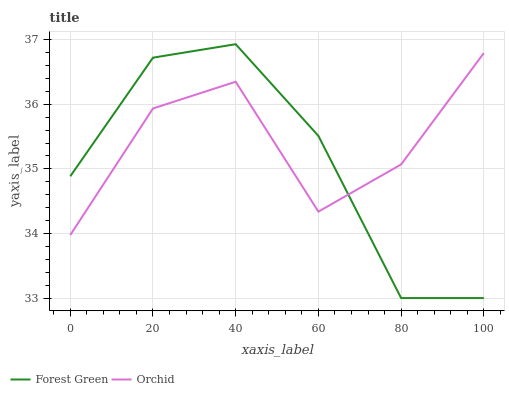Does Forest Green have the minimum area under the curve?
Answer yes or no. Yes. Does Orchid have the maximum area under the curve?
Answer yes or no. Yes. Does Orchid have the minimum area under the curve?
Answer yes or no. No. Is Forest Green the smoothest?
Answer yes or no. Yes. Is Orchid the roughest?
Answer yes or no. Yes. Is Orchid the smoothest?
Answer yes or no. No. Does Orchid have the lowest value?
Answer yes or no. No. Does Forest Green have the highest value?
Answer yes or no. Yes. Does Orchid have the highest value?
Answer yes or no. No. Does Forest Green intersect Orchid?
Answer yes or no. Yes. Is Forest Green less than Orchid?
Answer yes or no. No. Is Forest Green greater than Orchid?
Answer yes or no. No. 